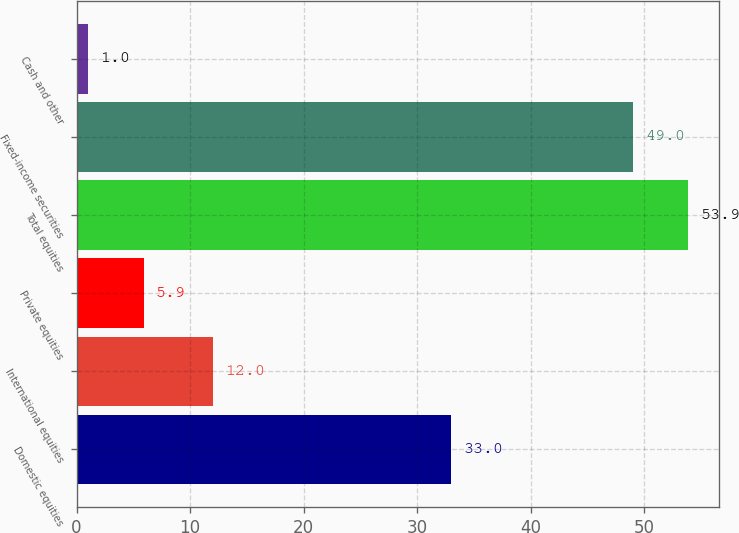<chart> <loc_0><loc_0><loc_500><loc_500><bar_chart><fcel>Domestic equities<fcel>International equities<fcel>Private equities<fcel>Total equities<fcel>Fixed-income securities<fcel>Cash and other<nl><fcel>33<fcel>12<fcel>5.9<fcel>53.9<fcel>49<fcel>1<nl></chart> 